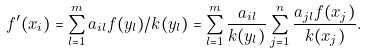<formula> <loc_0><loc_0><loc_500><loc_500>f ^ { \prime } ( x _ { i } ) = \sum ^ { m } _ { l = 1 } a _ { i l } f ( y _ { l } ) / k ( y _ { l } ) = \sum ^ { m } _ { l = 1 } \frac { a _ { i l } } { k ( y _ { l } ) } \sum ^ { n } _ { j = 1 } \frac { a _ { j l } f ( x _ { j } ) } { k ( x _ { j } ) } .</formula> 